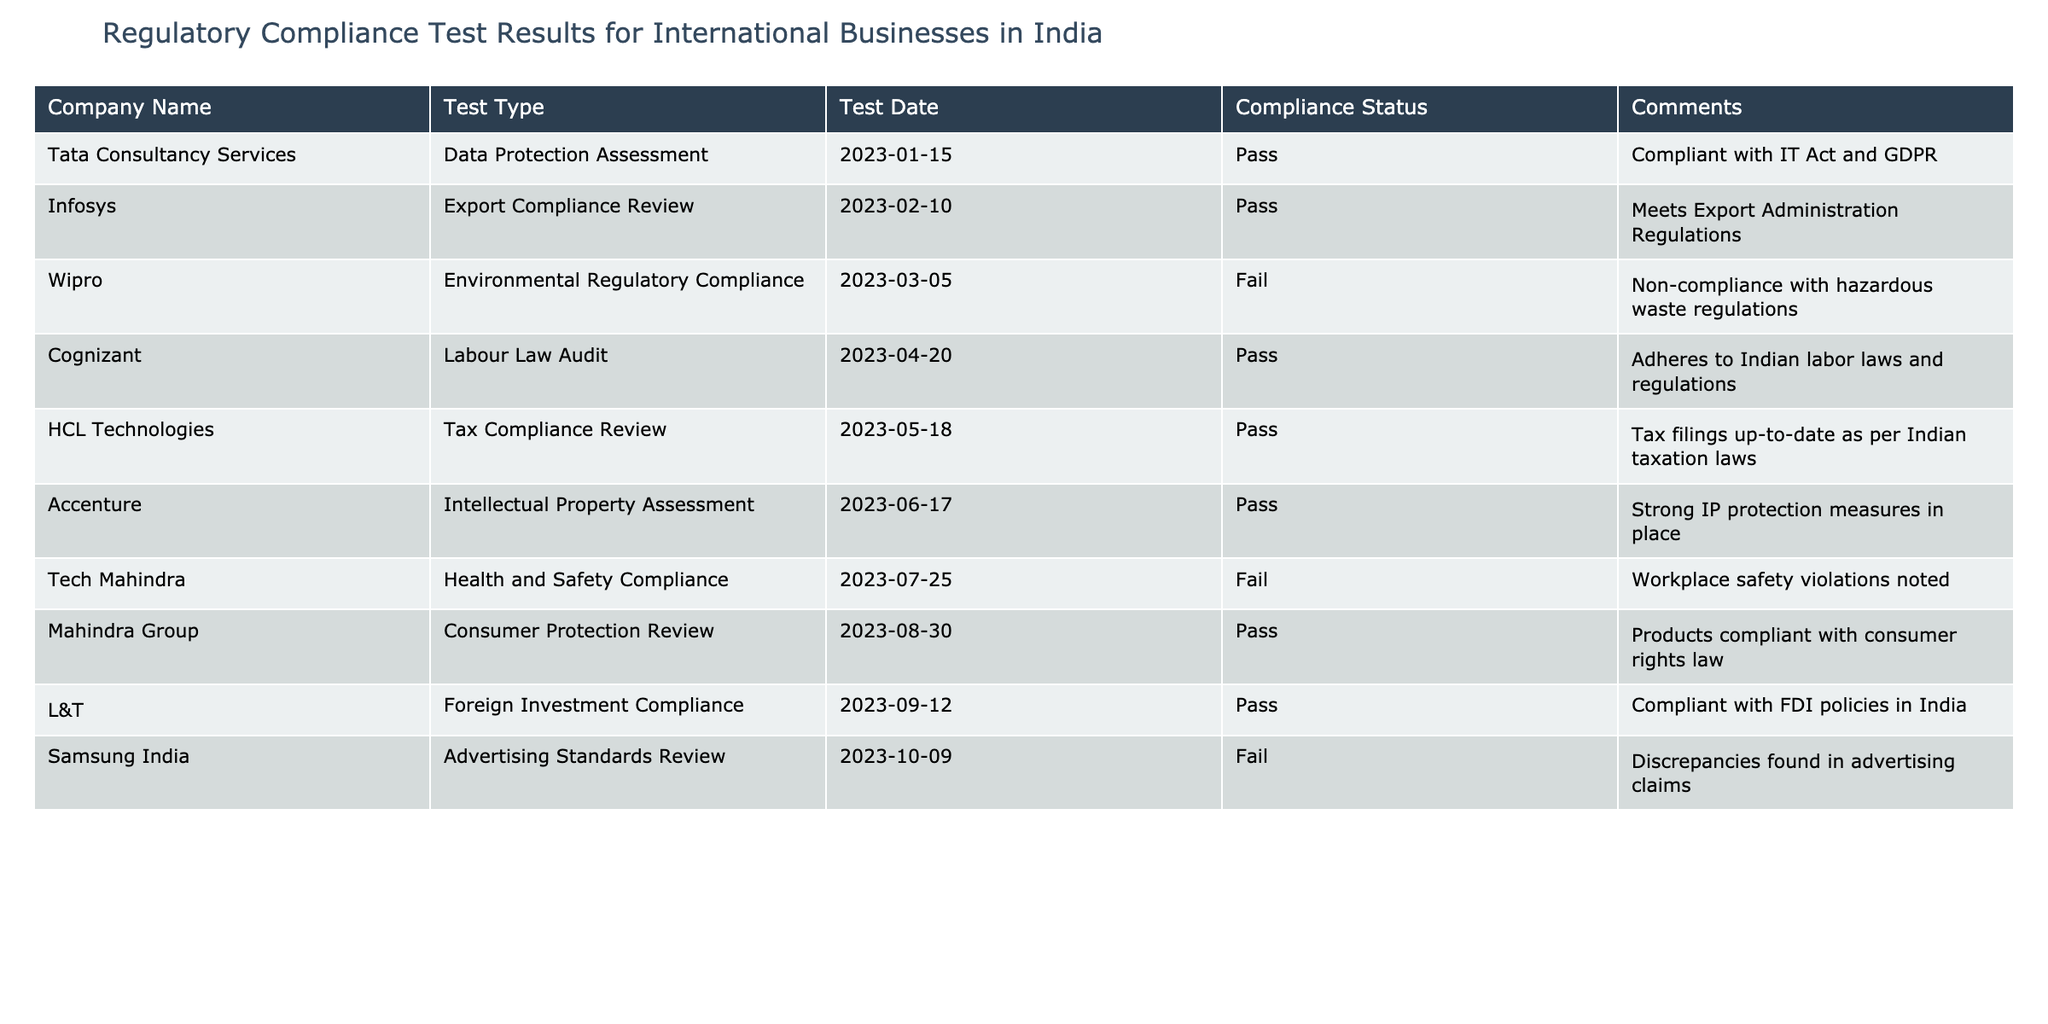What companies passed the compliance tests? By looking at the 'Compliance Status' column, we can see that the companies with a status of 'Pass' are Tata Consultancy Services, Infosys, Cognizant, HCL Technologies, Accenture, Mahindra Group, and L&T.
Answer: Tata Consultancy Services, Infosys, Cognizant, HCL Technologies, Accenture, Mahindra Group, L&T What type of compliance test did Wipro fail? The 'Test Type' column shows that Wipro underwent an 'Environmental Regulatory Compliance' assessment and the 'Compliance Status' indicates it failed.
Answer: Environmental Regulatory Compliance Which companies passed the tests in 2023? We check the 'Test Date' and 'Compliance Status' columns; companies that passed their tests are Tata Consultancy Services, Infosys, Cognizant, HCL Technologies, Accenture, Mahindra Group, and L&T, all of which have dates within the year 2023.
Answer: Tata Consultancy Services, Infosys, Cognizant, HCL Technologies, Accenture, Mahindra Group, L&T How many companies failed their compliance tests? By counting the rows where 'Compliance Status' is marked as 'Fail,' we find that there are three companies: Wipro, Tech Mahindra, and Samsung India.
Answer: Three Did any company fail the Labour Law Audit? Looking at the 'Test Type' column, Cognizant passed its Labour Law Audit, indicated by a 'Pass' in the 'Compliance Status' column. Thus, no company failed this specific test.
Answer: No What is the common characteristic of companies that passed compliance tests? Reviewing the table, a common characteristic is that the companies that passed generally adhere to respective regulations, such as tax laws, consumer rights laws, and labor laws as noted in their comments. They demonstrate a proactive approach to compliance as indicated by their passing status.
Answer: They adhere to respective regulations If Samsung India made discrepancies in advertising claims, what does that indicate about its compliance status? The 'Compliance Status' for Samsung India is 'Fail' and the comments detail discrepancies found in advertising claims, indicating it did not meet the necessary advertising standards.
Answer: It indicates non-compliance What is the majority status of compliance in this table? To determine this, we count the occurrences of 'Pass' and 'Fail.' There are 7 passes and 3 fails, so the majority status is 'Pass.'
Answer: Pass Which test had the earliest test date? Checking the 'Test Date' column reveals that the earliest date is January 15, 2023, for the Data Protection Assessment conducted by Tata Consultancy Services.
Answer: Data Protection Assessment What can be inferred from the comment regarding Tech Mahindra's compliance status? The comment states that there were 'Workplace safety violations noted,' which infers that there are significant issues concerning health and safety compliance for Tech Mahindra despite their attempts to meet regulations.
Answer: Significant health and safety issues 